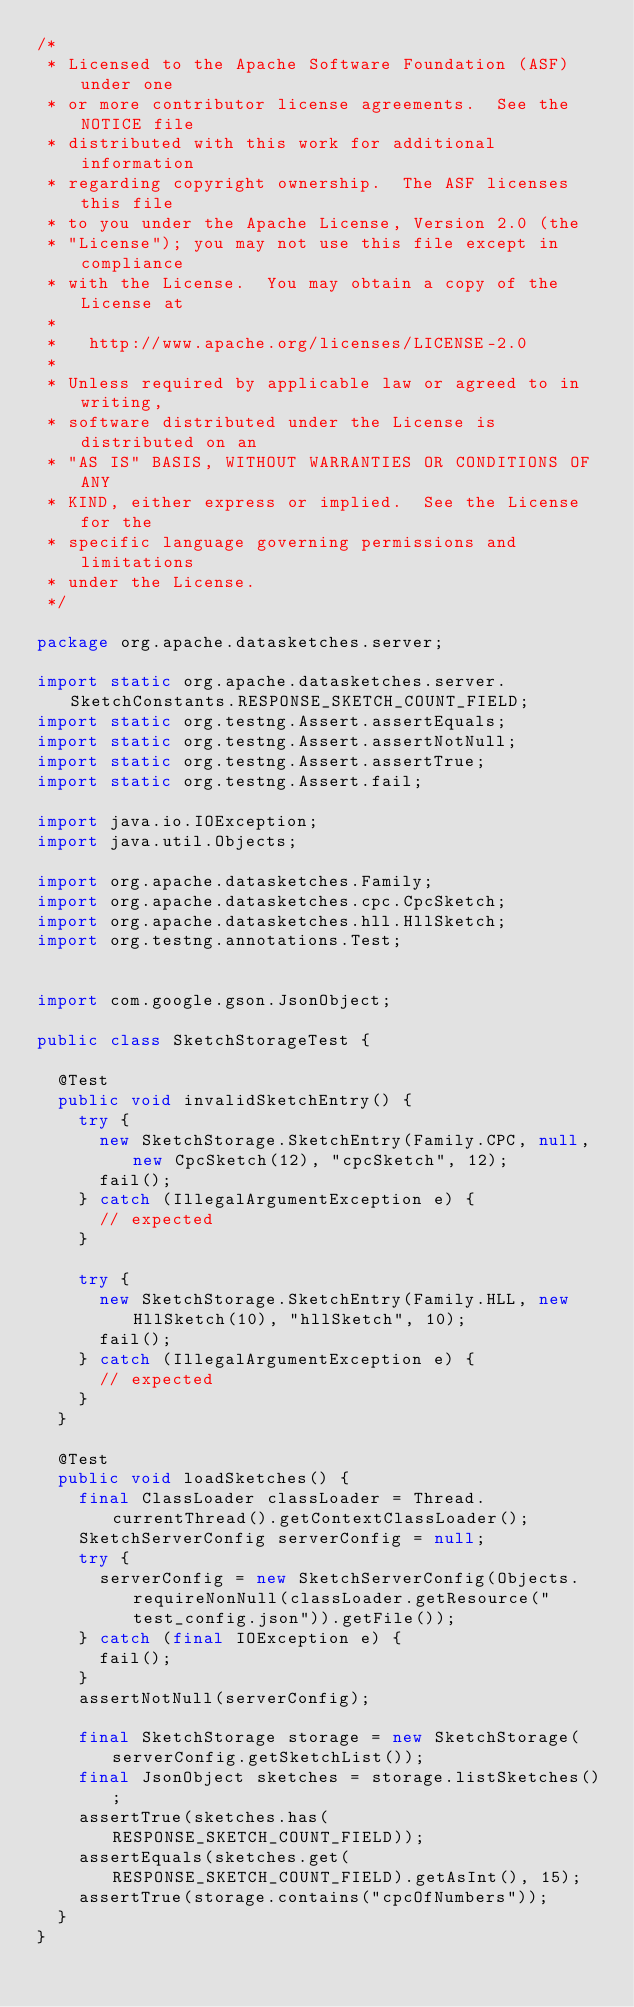Convert code to text. <code><loc_0><loc_0><loc_500><loc_500><_Java_>/*
 * Licensed to the Apache Software Foundation (ASF) under one
 * or more contributor license agreements.  See the NOTICE file
 * distributed with this work for additional information
 * regarding copyright ownership.  The ASF licenses this file
 * to you under the Apache License, Version 2.0 (the
 * "License"); you may not use this file except in compliance
 * with the License.  You may obtain a copy of the License at
 *
 *   http://www.apache.org/licenses/LICENSE-2.0
 *
 * Unless required by applicable law or agreed to in writing,
 * software distributed under the License is distributed on an
 * "AS IS" BASIS, WITHOUT WARRANTIES OR CONDITIONS OF ANY
 * KIND, either express or implied.  See the License for the
 * specific language governing permissions and limitations
 * under the License.
 */

package org.apache.datasketches.server;

import static org.apache.datasketches.server.SketchConstants.RESPONSE_SKETCH_COUNT_FIELD;
import static org.testng.Assert.assertEquals;
import static org.testng.Assert.assertNotNull;
import static org.testng.Assert.assertTrue;
import static org.testng.Assert.fail;

import java.io.IOException;
import java.util.Objects;

import org.apache.datasketches.Family;
import org.apache.datasketches.cpc.CpcSketch;
import org.apache.datasketches.hll.HllSketch;
import org.testng.annotations.Test;


import com.google.gson.JsonObject;

public class SketchStorageTest {

  @Test
  public void invalidSketchEntry() {
    try {
      new SketchStorage.SketchEntry(Family.CPC, null, new CpcSketch(12), "cpcSketch", 12);
      fail();
    } catch (IllegalArgumentException e) {
      // expected
    }

    try {
      new SketchStorage.SketchEntry(Family.HLL, new HllSketch(10), "hllSketch", 10);
      fail();
    } catch (IllegalArgumentException e) {
      // expected
    }
  }

  @Test
  public void loadSketches() {
    final ClassLoader classLoader = Thread.currentThread().getContextClassLoader();
    SketchServerConfig serverConfig = null;
    try {
      serverConfig = new SketchServerConfig(Objects.requireNonNull(classLoader.getResource("test_config.json")).getFile());
    } catch (final IOException e) {
      fail();
    }
    assertNotNull(serverConfig);

    final SketchStorage storage = new SketchStorage(serverConfig.getSketchList());
    final JsonObject sketches = storage.listSketches();
    assertTrue(sketches.has(RESPONSE_SKETCH_COUNT_FIELD));
    assertEquals(sketches.get(RESPONSE_SKETCH_COUNT_FIELD).getAsInt(), 15);
    assertTrue(storage.contains("cpcOfNumbers"));
  }
}
</code> 